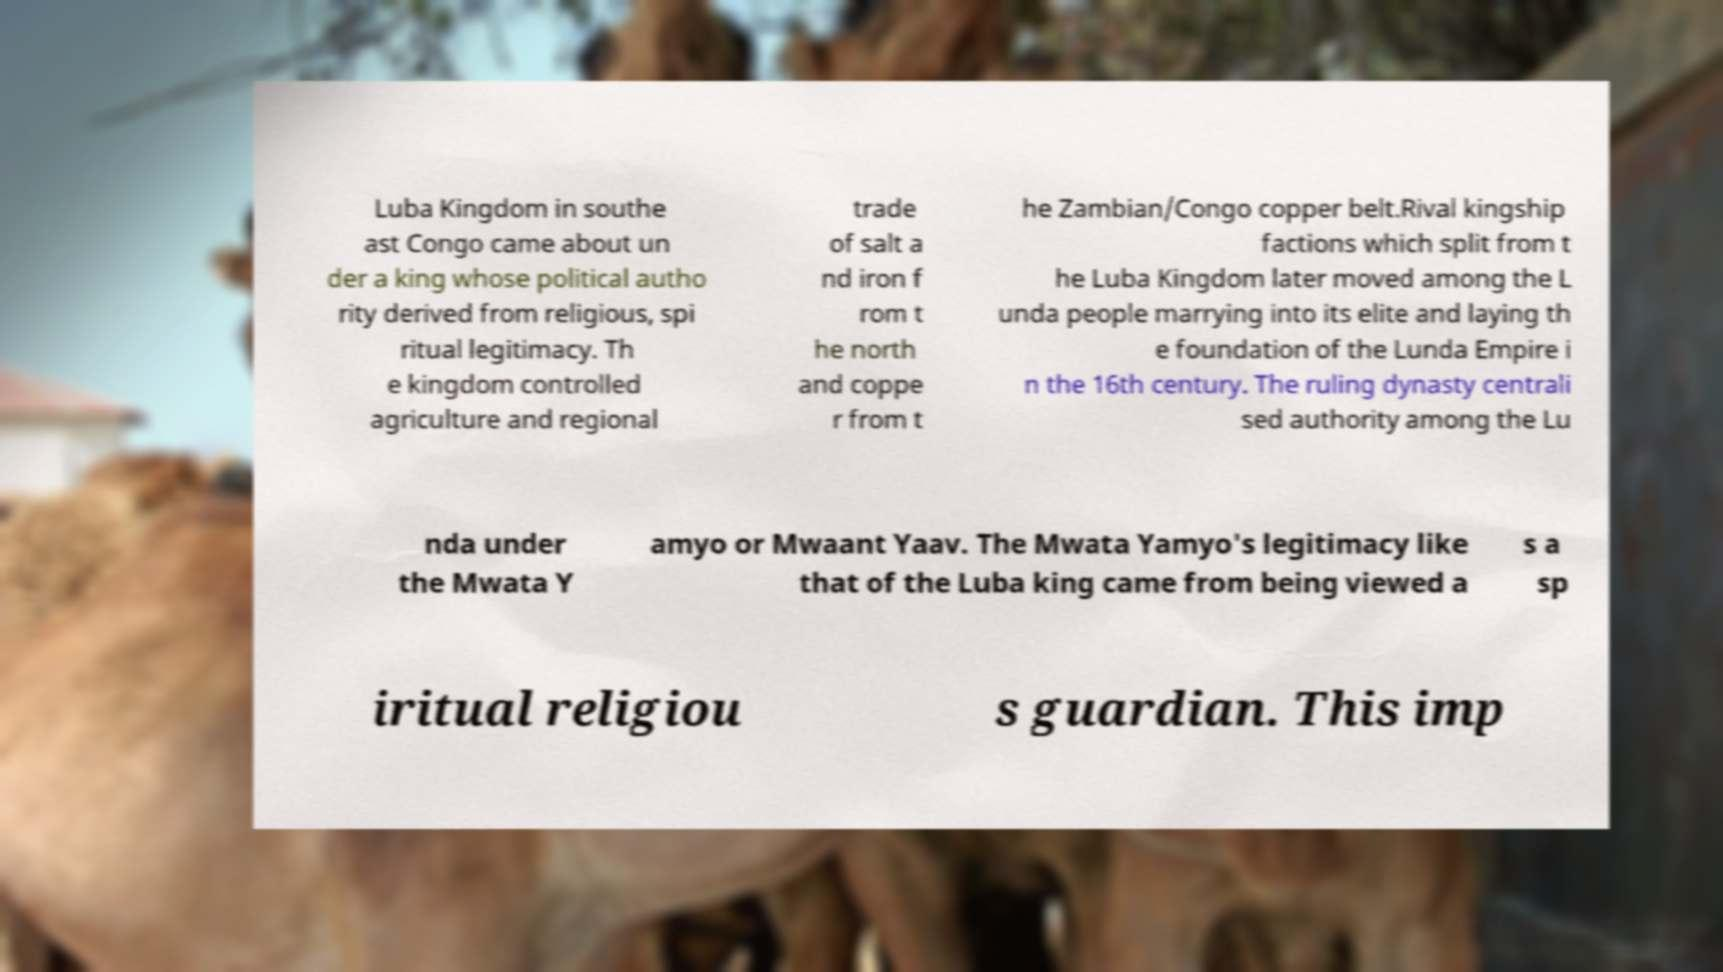What messages or text are displayed in this image? I need them in a readable, typed format. Luba Kingdom in southe ast Congo came about un der a king whose political autho rity derived from religious, spi ritual legitimacy. Th e kingdom controlled agriculture and regional trade of salt a nd iron f rom t he north and coppe r from t he Zambian/Congo copper belt.Rival kingship factions which split from t he Luba Kingdom later moved among the L unda people marrying into its elite and laying th e foundation of the Lunda Empire i n the 16th century. The ruling dynasty centrali sed authority among the Lu nda under the Mwata Y amyo or Mwaant Yaav. The Mwata Yamyo's legitimacy like that of the Luba king came from being viewed a s a sp iritual religiou s guardian. This imp 